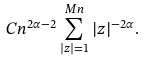<formula> <loc_0><loc_0><loc_500><loc_500>C n ^ { 2 \alpha - 2 } \sum _ { | z | = 1 } ^ { M n } { | z | ^ { - 2 \alpha } } .</formula> 